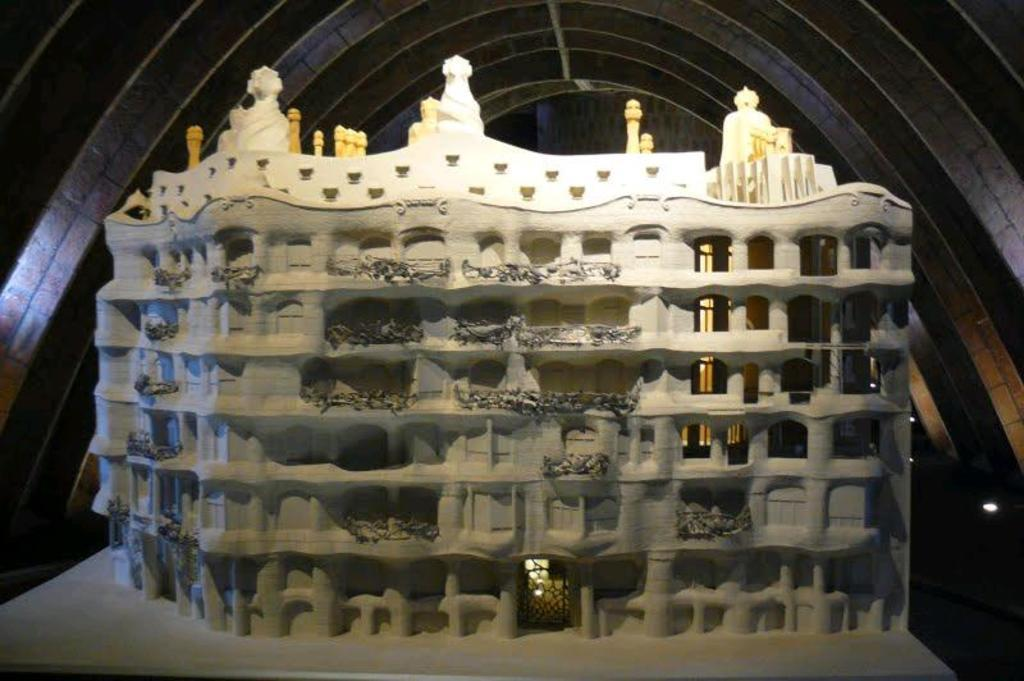What is the main structure visible in the image? There is a casa mila in the image. What architectural elements can be seen in the image? There are poles, windows, and sculptures visible in the image. What other features are present in the image? There are grills and plants in the image. What can be seen in the background of the image? There is a wall visible in the background of the image. What message is written on the sign in the image? There is no sign present in the image, so no message can be read. 